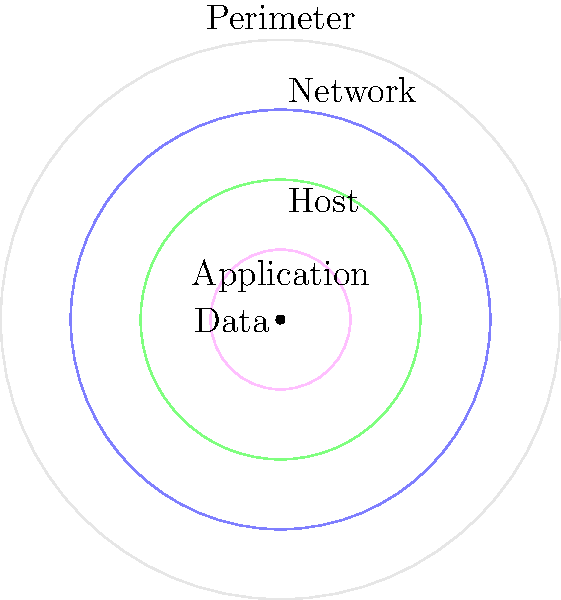In this network security model, which layer would be most likely to handle a firewall's packet filtering function? Think of it as casting the perfect supporting actor for your network's security play! Let's break this down step-by-step, like we're building a comedy sketch:

1. The diagram shows a layered approach to network security, represented by concentric circles. This is similar to the "defense in depth" concept in cybersecurity.

2. Starting from the outermost layer, we have:
   - Perimeter: The first line of defense, like the bouncer at a comedy club.
   - Network: Handles network-level traffic, think of it as the lobby where people mingle.
   - Host: Focuses on individual devices, like the green room for performers.
   - Application: Deals with specific software, akin to the actual stage.
   - Data: The core, representing the punchline of your joke.

3. A firewall's primary function is to filter network traffic based on predetermined security rules. It acts as a barrier between trusted internal networks and untrusted external networks.

4. Packet filtering, a basic function of firewalls, operates at the network layer of the OSI model. It examines the headers of data packets to determine whether they should be allowed or blocked.

5. In our comedy club analogy, packet filtering would be like checking the guest list at the entrance of the club, which happens in the lobby (Network layer) rather than at the perimeter or inside the club.

Therefore, the Network layer would be most appropriate for handling a firewall's packet filtering function.
Answer: Network layer 